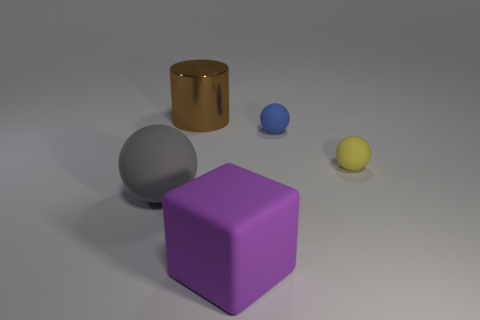Are the brown object and the ball left of the large purple block made of the same material?
Ensure brevity in your answer.  No. There is a large matte object that is in front of the big matte ball; what shape is it?
Keep it short and to the point. Cube. Are there the same number of blue cylinders and big blocks?
Provide a short and direct response. No. How many other objects are the same material as the small yellow object?
Your response must be concise. 3. How big is the blue matte sphere?
Your response must be concise. Small. How many other objects are the same color as the metal cylinder?
Offer a very short reply. 0. There is a thing that is both left of the small blue matte thing and behind the gray matte thing; what color is it?
Your answer should be compact. Brown. What number of large blocks are there?
Offer a very short reply. 1. Do the block and the brown thing have the same material?
Provide a succinct answer. No. The large rubber thing that is to the right of the large metallic thing that is behind the large matte thing behind the big purple block is what shape?
Provide a short and direct response. Cube. 